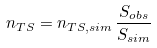<formula> <loc_0><loc_0><loc_500><loc_500>n _ { T S } = n _ { T S , s i m } \, \frac { S _ { o b s } } { S _ { s i m } }</formula> 